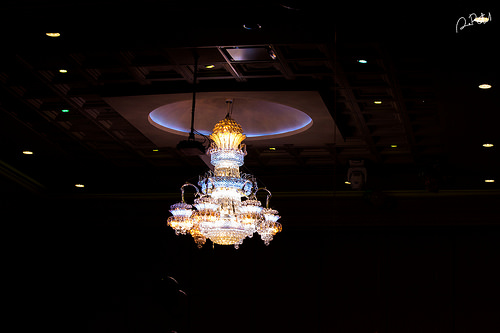<image>
Is the light under the dome? Yes. The light is positioned underneath the dome, with the dome above it in the vertical space. 